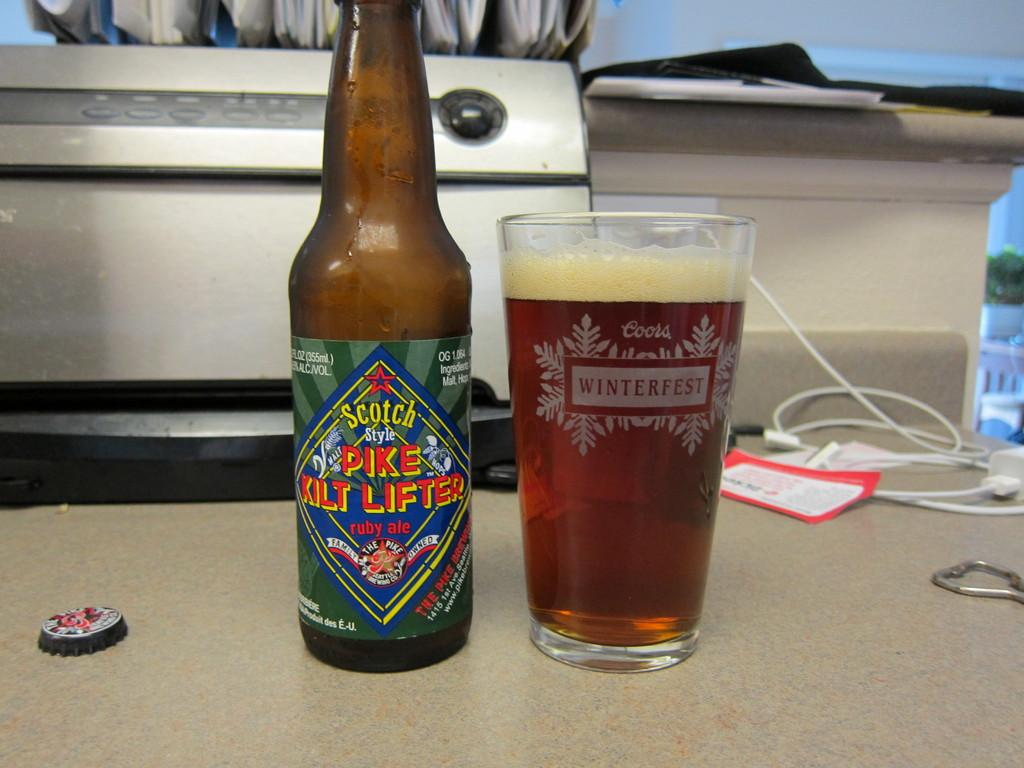<image>
Relay a brief, clear account of the picture shown. A bottle of Scotch Style PIKE KILT LIFTER ruby ale is on a table and glass of it is next to it with Coors WINTERFEST on the glass itself. 